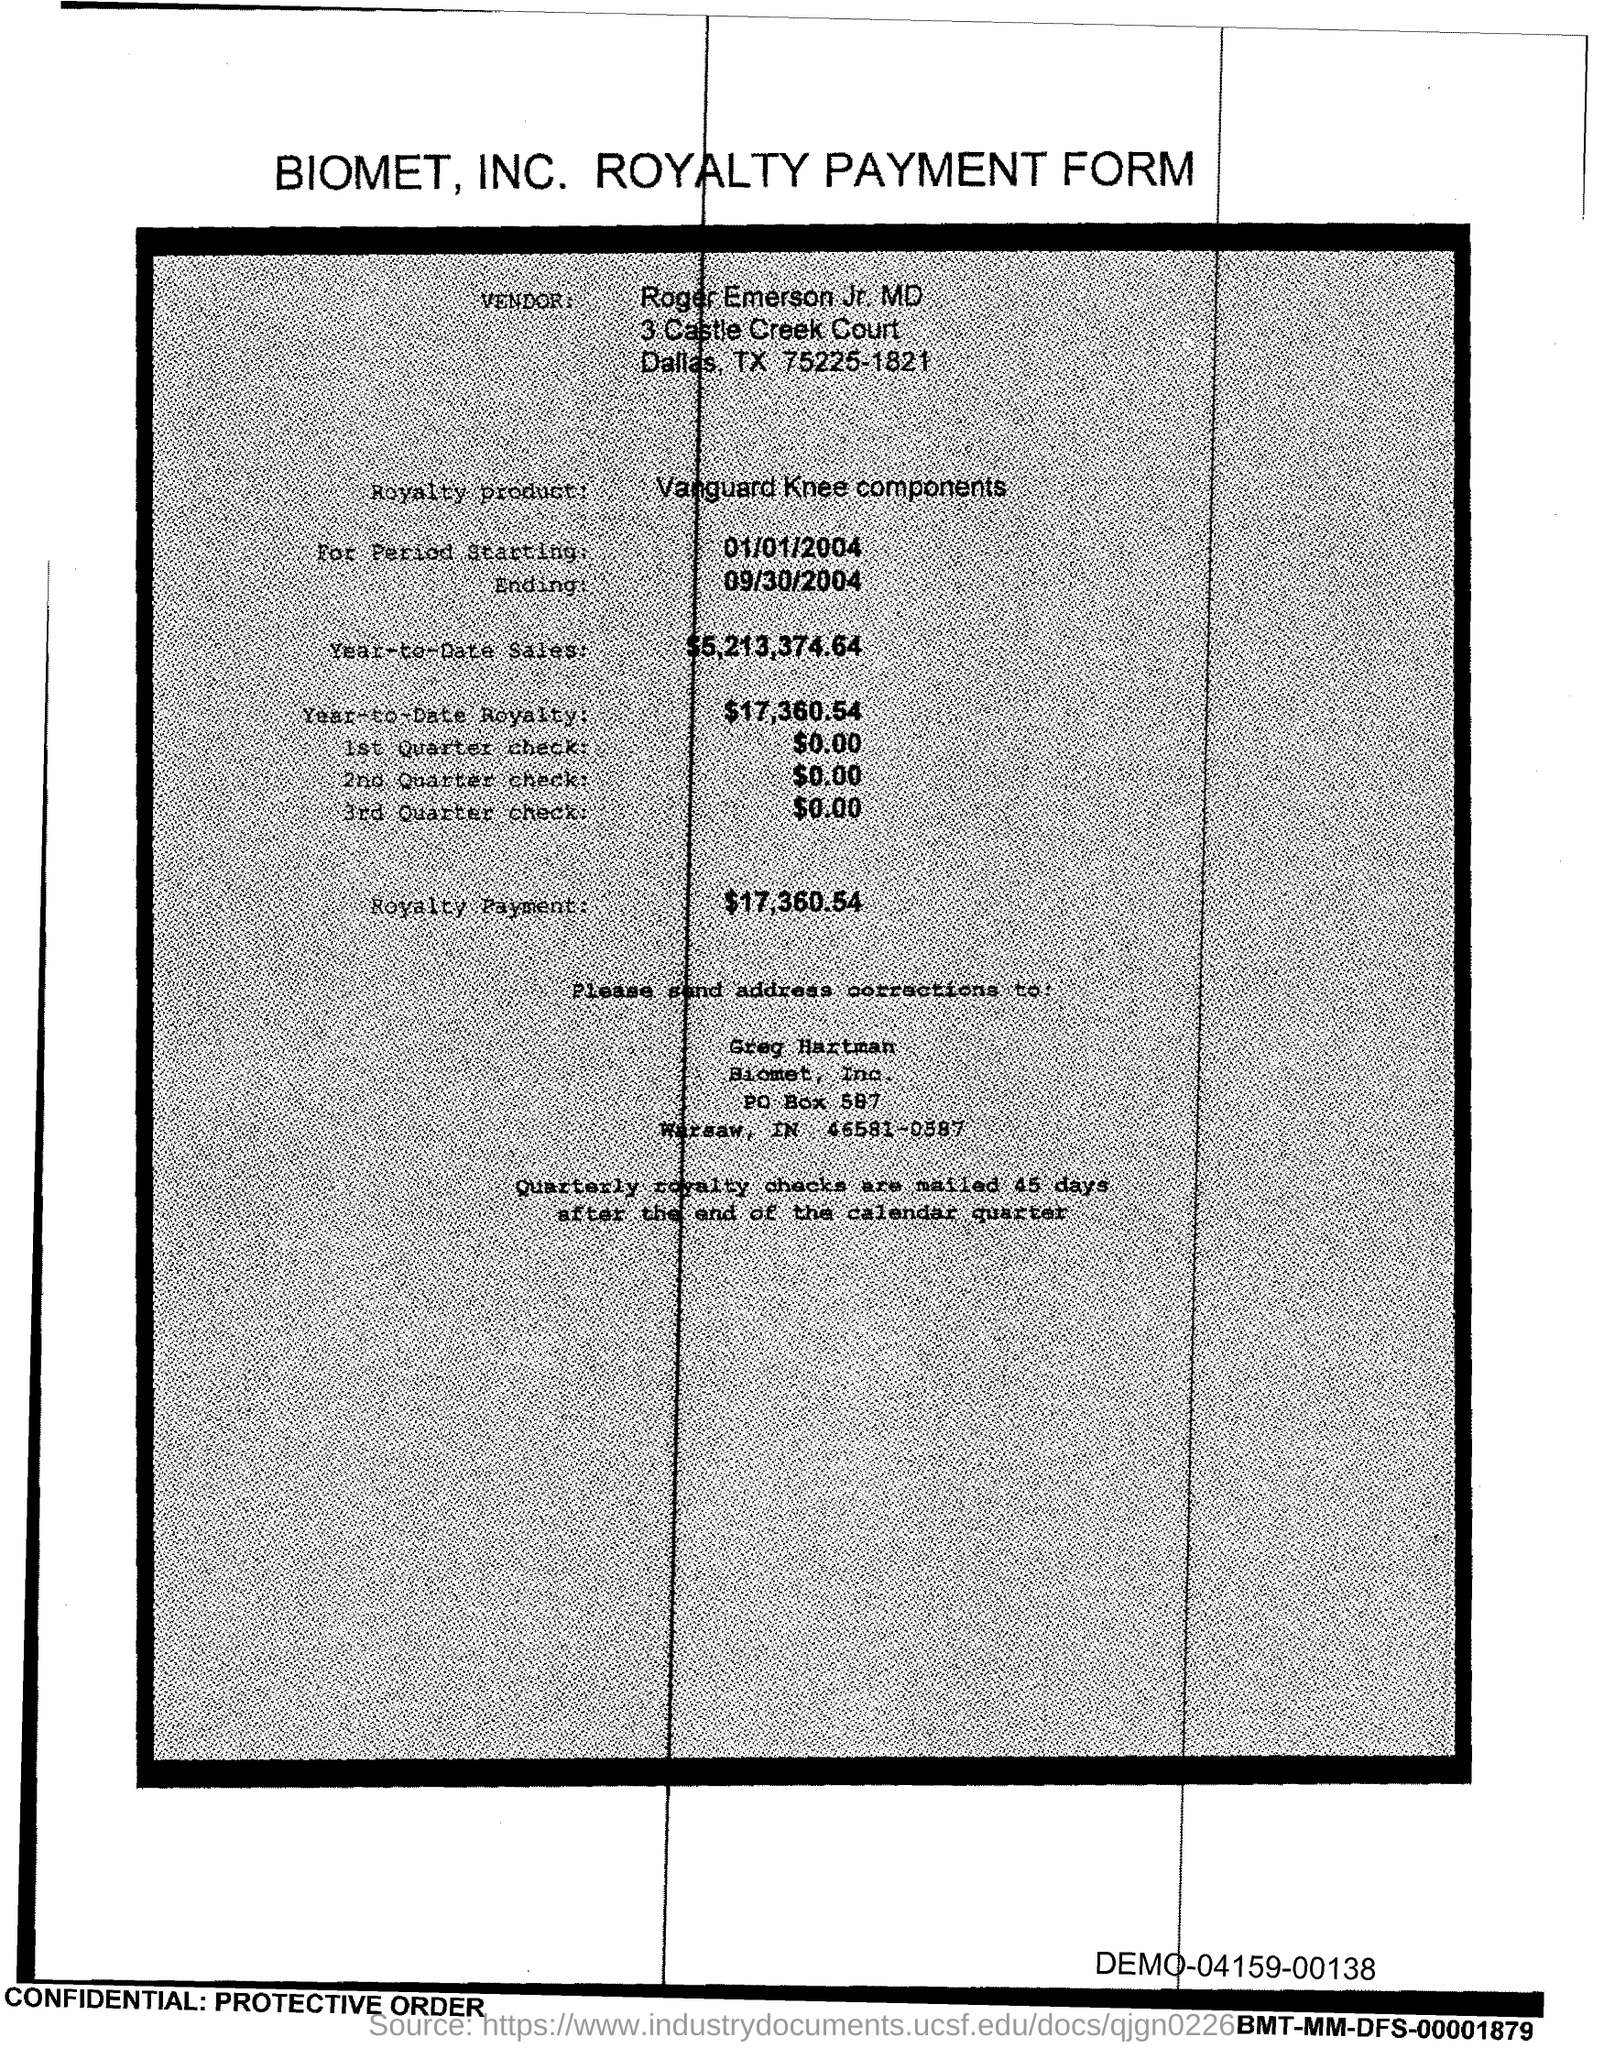Draw attention to some important aspects in this diagram. The address corrections should be sent to Greg Hartman, The Royalty product is Vanguard Knee Components, which is a line of knee components designed to provide exceptional performance and durability for joint replacement surgeries. The starting date for the data is January 1, 2004. The year-to-date royalty as of now is 17,360.54... The ending period is September 30, 2004. 